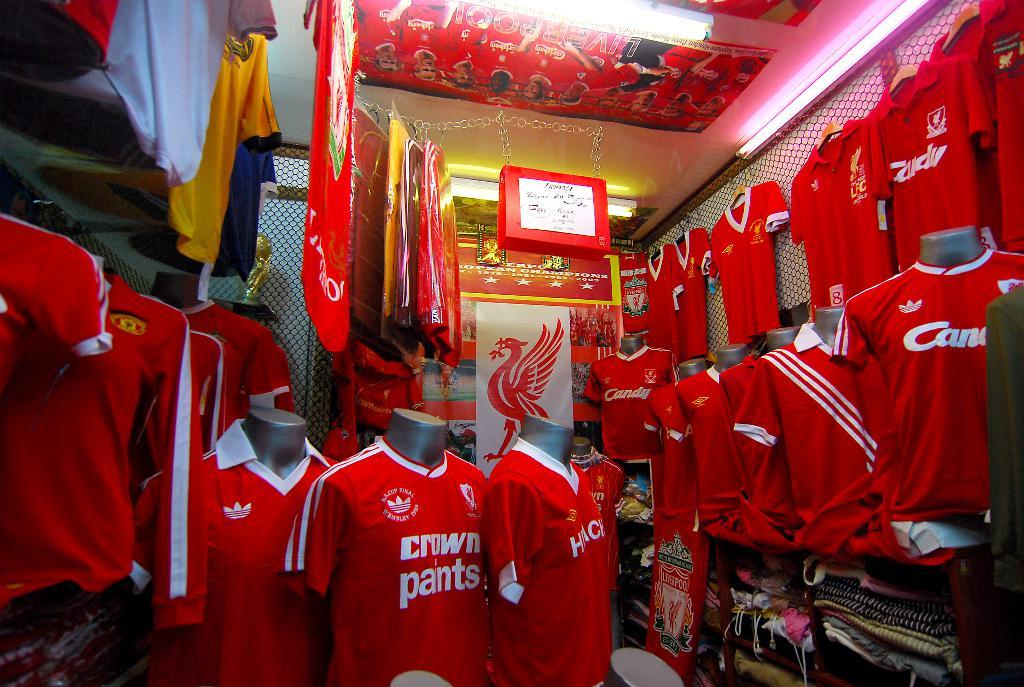Provide a one-sentence caption for the provided image. A store stocked full of red crown paints jerseys. 